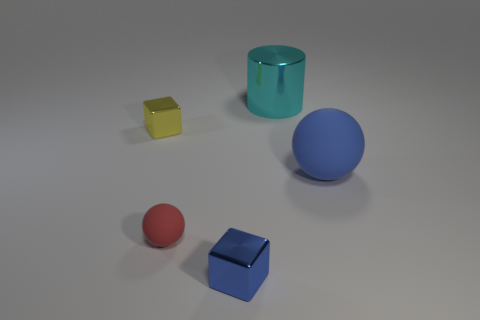Can you speculate on the material composition of these objects? Based on their appearance, the objects could be made from various materials. The matte finish suggests they could be made of colored plastic or painted wood, though actual materials are not specified in this rendering. 